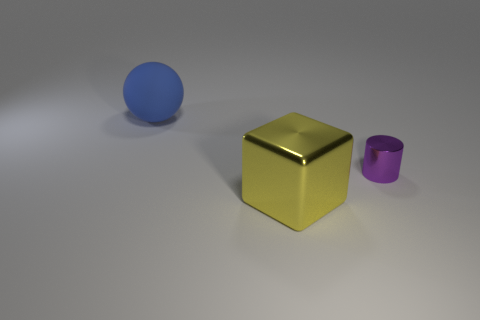Is the number of big spheres that are to the left of the tiny purple object the same as the number of tiny cylinders? After carefully examining the image, it appears that there is one large blue sphere positioned to the left of the small purple cylinder. Comparing this to cylinders, there is only the one tiny purple cylinder visible. Therefore, the count of big spheres to the left of the tiny purple object is indeed equal to the number of tiny cylinders present in the image. 